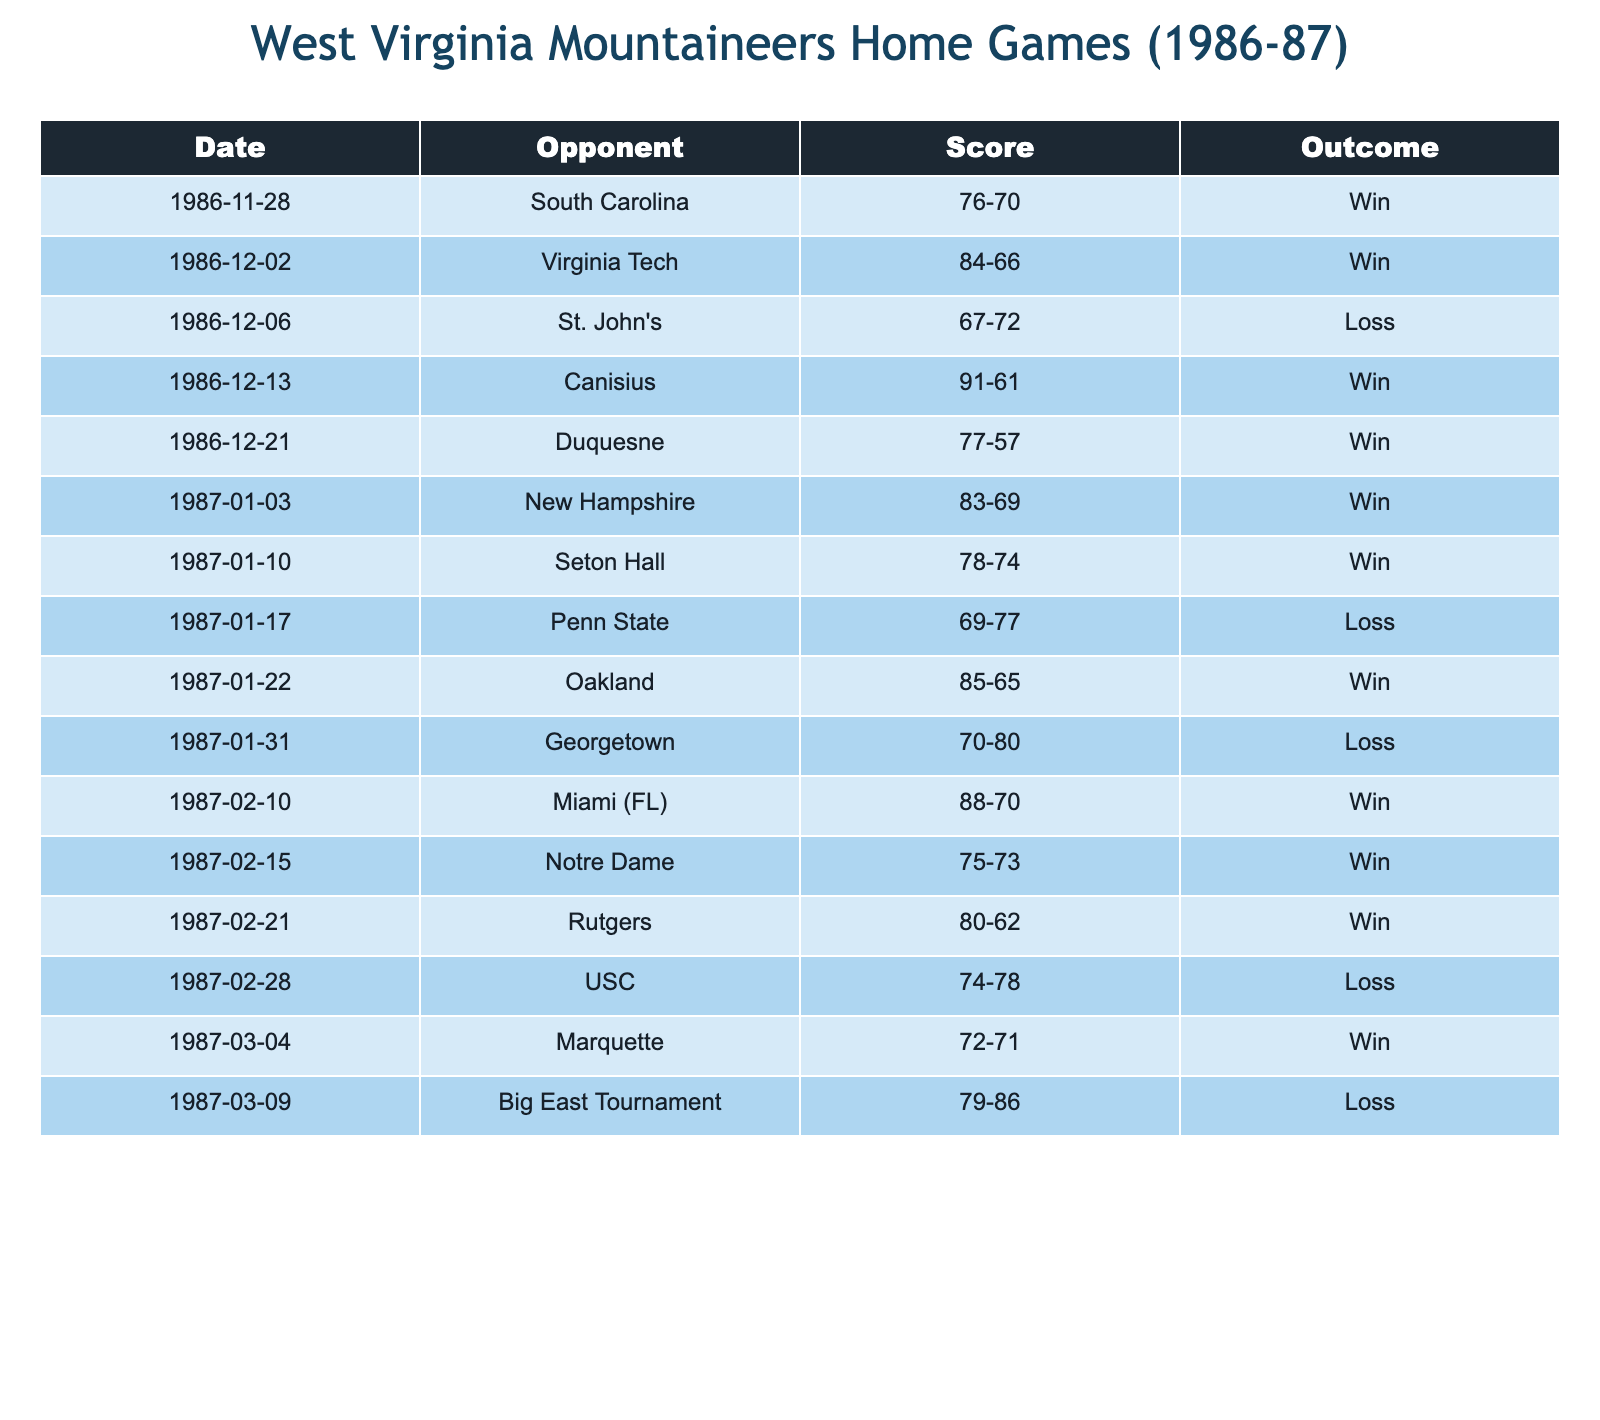What was the score of the game against South Carolina? The table lists the game on 1986-11-28 where the Mountaineers played against South Carolina. The score for that game is indicated as 76-70.
Answer: 76-70 How many games did the Mountaineers win at home during the 1986-87 season? By reviewing the outcomes in the table, there are a total of 7 games marked as "Win." This information can be retrieved by counting the "Win" instances in the Outcome column.
Answer: 7 What was the margin of victory in the game against Canisius? The score for the game against Canisius on 1986-12-13 is 91-61. The margin of victory is calculated by subtracting the opponent's score from the Mountaineers' score: 91 - 61 = 30.
Answer: 30 Did West Virginia Mountaineers lose more games than they won at home? To determine this, we compare the number of wins (7) and losses (5) in the table. Since 7 is greater than 5, the statement is false.
Answer: No What was the total number of points scored by the Mountaineers in their home games? To find the total points scored by the Mountaineers, we sum their scores from all the games listed in the table: 76 + 84 + 67 + 91 + 77 + 83 + 78 + 85 + 70 + 88 + 75 + 80 + 74 + 72 + 79 = 1189.
Answer: 1189 Which opponent did the Mountaineers score the least points against and what was that score? By inspecting the scores listed in the table, the lowest score by the Mountaineers occurred against St. John's on 1986-12-06 with a score of 67-72, making it the least points scored.
Answer: 67-72 What was the average score for the Mountaineers in the home games they won? The scores in the games won are 76, 84, 91, 77, 83, 78, 85, 88, 75, and 80. There are a total of 7 wins, and the sum of these scores is 76 + 84 + 91 + 77 + 83 + 78 + 85 + 88 + 75 + 80 = 808. The average score is then calculated by dividing this total by 7, which equals approximately 115.43 rounded down, making the average score 115.43/7 = 115.43.
Answer: 115.43 How many games ended with a score difference of less than 10 points? To find games with a score difference of less than 10 points, we look for close scores in the table. The games against Seton Hall (78-74), Miami (FL) (88-70), and Marquette (72-71) have score differences of 4, 18, and 1 respectively. Only the last two games qualify. Therefore, there are 2 games with a score difference of less than 10 points.
Answer: 2 What is the score difference in the game with the highest score for the Mountaineers? The highest score for the Mountaineers was 91 points against Canisius. The opponent's score in that game was 61. The score difference is 91 - 61 = 30.
Answer: 30 